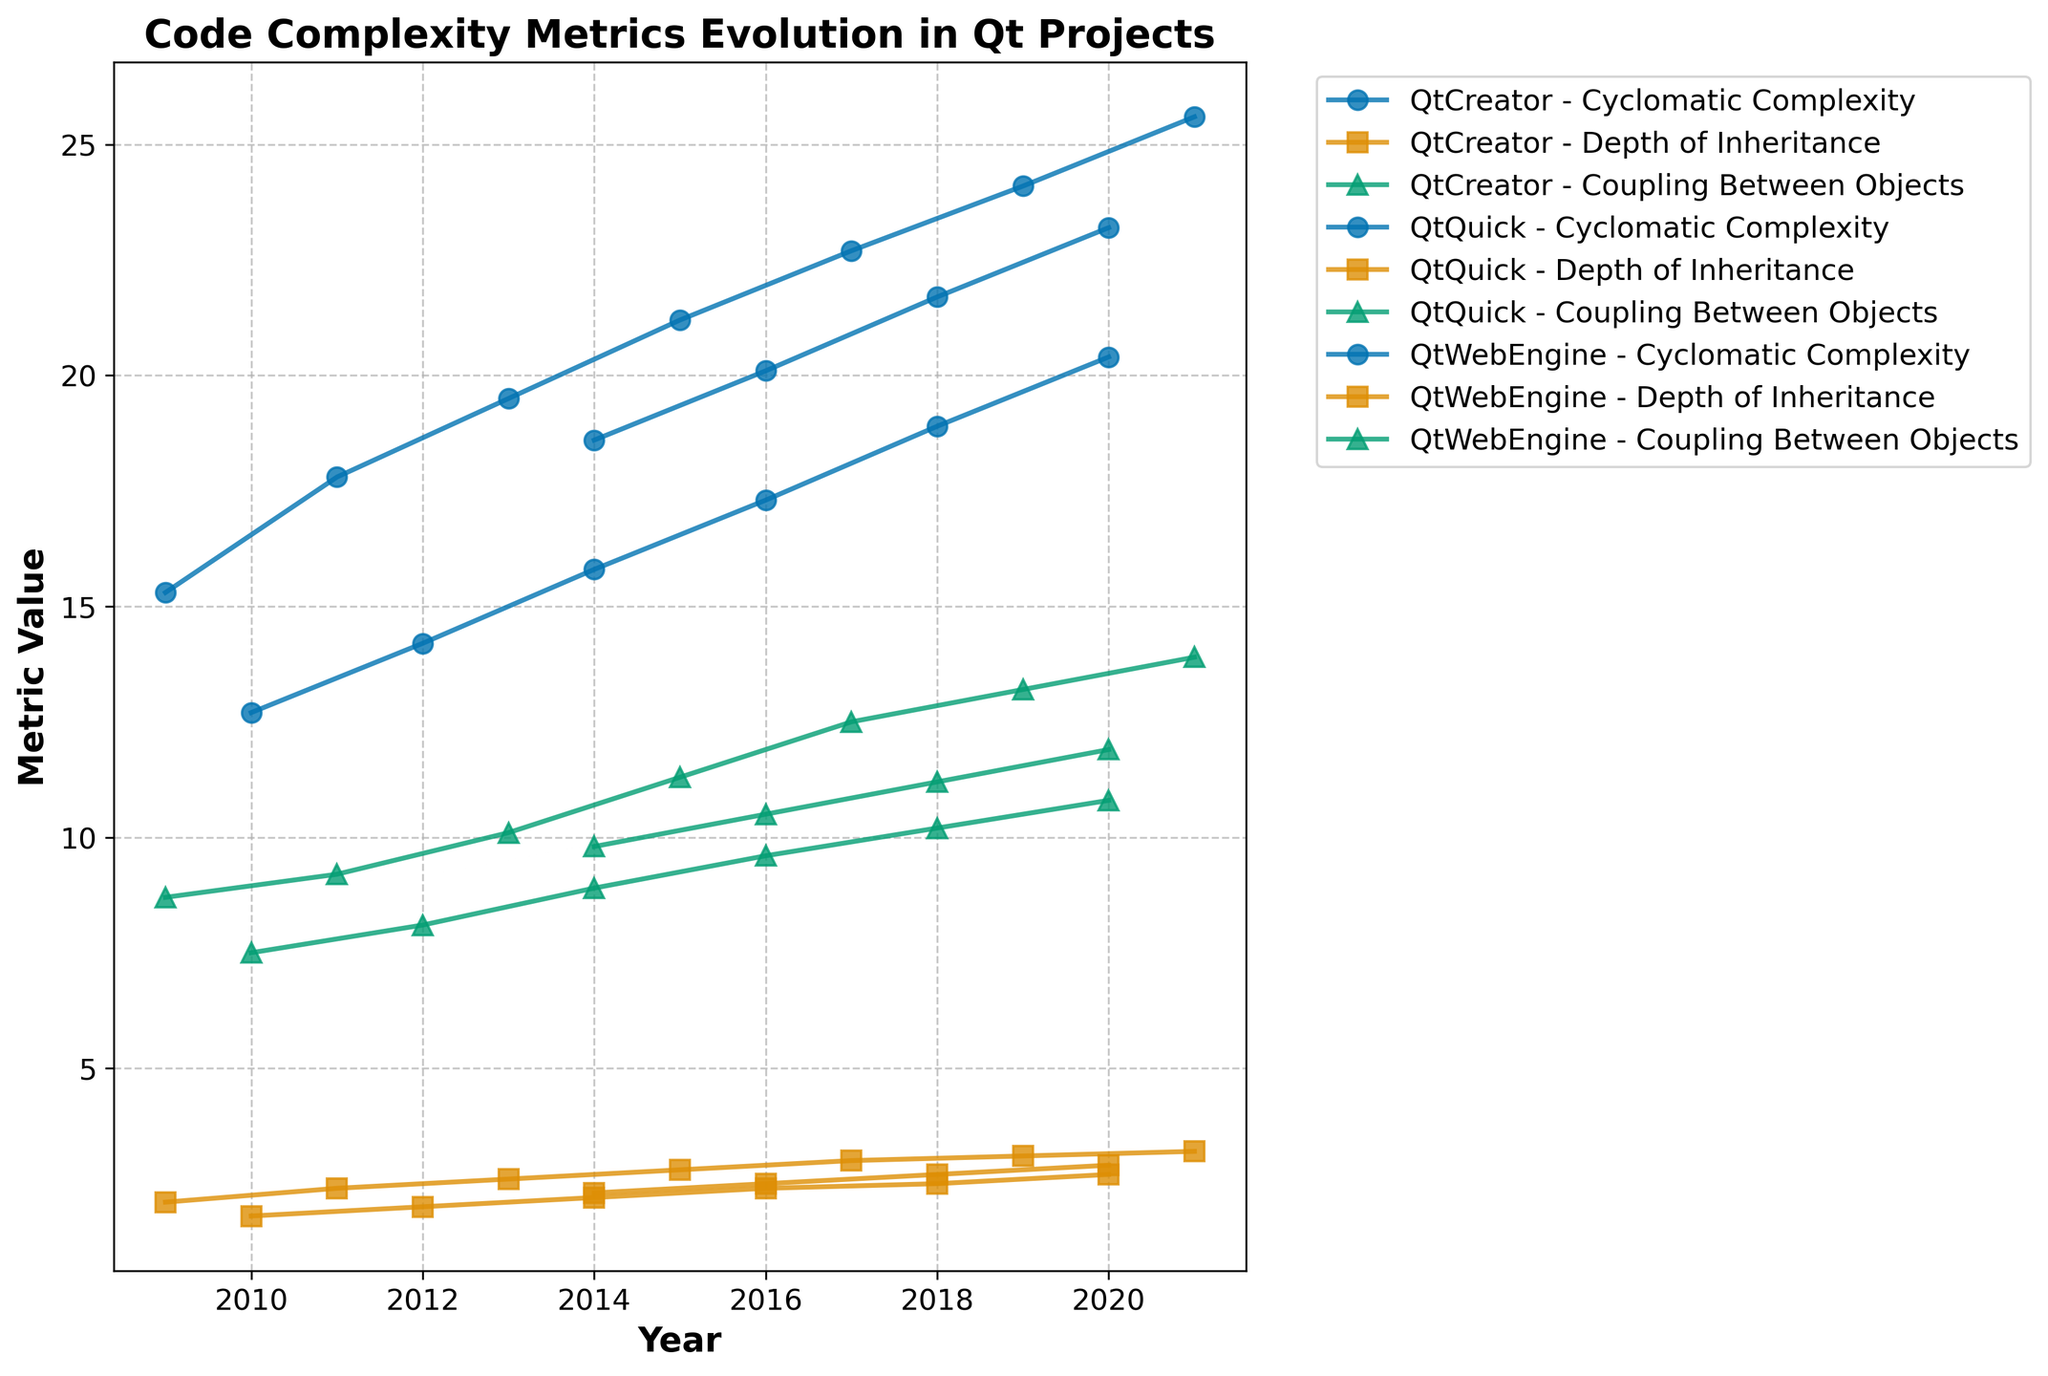What trend do you observe in the Cyclomatic Complexity of QtCreator from 2009 to 2021? The Cyclomatic Complexity of QtCreator increases steadily every two years from 15.3 in 2009 to 25.6 in 2021. This indicates a continuous increase in the code complexity over time.
Answer: Continual increase Between QtCreator and QtQuick, which project had a higher Depth of Inheritance in the year 2015? Comparing the data points in the year 2015, QtCreator had a Depth of Inheritance of 2.8, while QtQuick had a Depth of Inheritance of 2.2. Therefore, QtCreator had a higher Depth of Inheritance.
Answer: QtCreator Which project showed the highest Coupling Between Objects in the year 2020, and what was its value? In 2020, the plot shows three different values for Coupling Between Objects: QtQuick with 10.8, QtWebEngine with 11.9, and QtCreator with 13.2. QtCreator had the highest Coupling Between Objects with a value of 13.2.
Answer: QtCreator, 13.2 Is the Depth of Inheritance increasing at the same rate for all projects? By observing the trend lines for Depth of Inheritance over the years, all three projects (QtCreator, QtQuick, and QtWebEngine) show an increasing trend. However, the rate of increase varies. QtCreator shows a relatively steeper increase compared to QtQuick and QtWebEngine.
Answer: No What is the difference in Lines of Code between QtQuick and QtCreator in 2016? In 2016, QtQuick had 185,000 Lines of Code and QtCreator had 256,000 Lines of Code. The difference is 256,000 - 185,000 = 71,000.
Answer: 71,000 How did the Cyclomatic Complexity of QtWebEngine change from 2014 to 2018? For QtWebEngine, the Cyclomatic Complexity increased from 18.6 in 2014 to 21.7 in 2018. The change is 21.7 - 18.6 = 3.1.
Answer: Increased by 3.1 Which project had the lowest Depth of Inheritance in 2010 and what was the value? In 2010, the only project with available data was QtQuick, with a Depth of Inheritance of 1.8. This is the lowest since it is the only value presented.
Answer: QtQuick, 1.8 What is the average Cyclomatic Complexity of QtCreator from 2009 to 2015? The Cyclomatic Complexity values for QtCreator from 2009 to 2015 are 15.3, 17.8, 19.5, and 21.2. The average is (15.3 + 17.8 + 19.5 + 21.2) / 4 = 18.45.
Answer: 18.45 Compare the Depth of Inheritance of QtQuick and QtWebEngine in 2018. Which one is higher? In 2018, the Depth of Inheritance for QtQuick is 2.5 and for QtWebEngine is 2.7. Therefore, QtWebEngine has a higher Depth of Inheritance.
Answer: QtWebEngine 